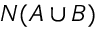Convert formula to latex. <formula><loc_0><loc_0><loc_500><loc_500>N ( A \cup B )</formula> 